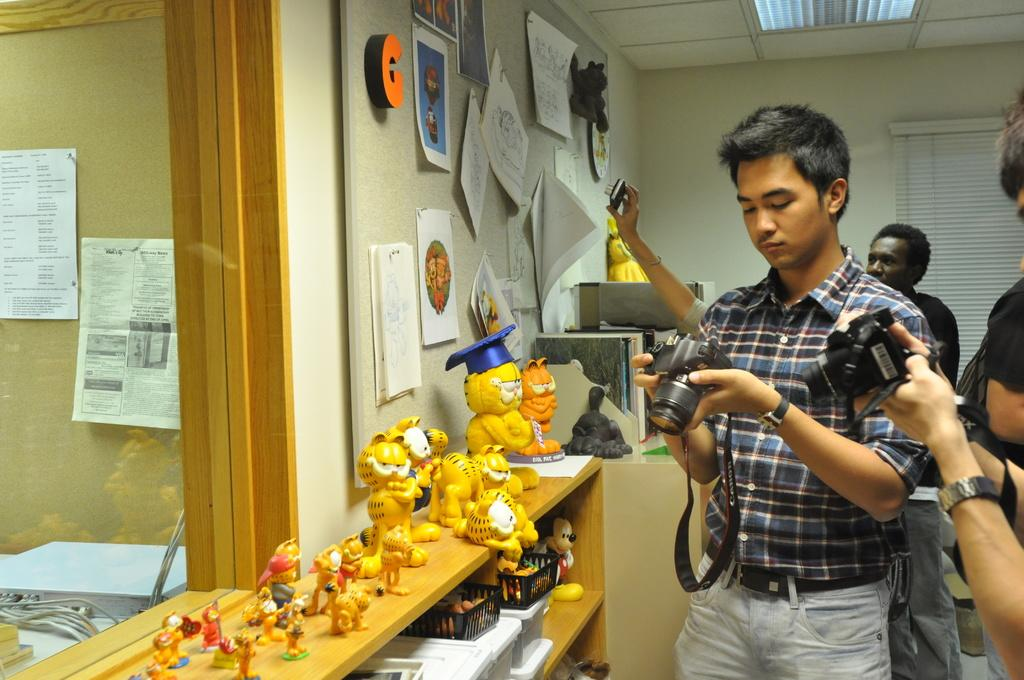Provide a one-sentence caption for the provided image. A group of photographers adjust their equipment near a bulletin board with an orange letter G pinned to it. 